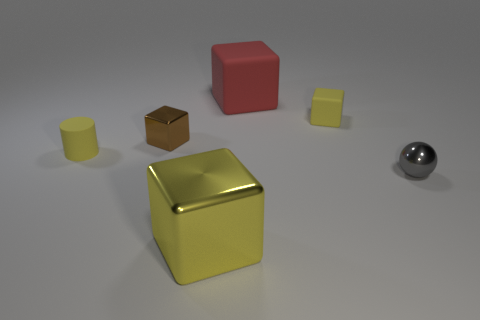What shape is the yellow object that is on the left side of the big red thing and behind the tiny metallic ball?
Your answer should be compact. Cylinder. Is the number of large red matte cubes that are to the left of the big yellow block the same as the number of tiny gray cylinders?
Keep it short and to the point. Yes. What number of objects are big red blocks or gray shiny spheres that are right of the yellow cylinder?
Your answer should be compact. 2. Is there another metal thing of the same shape as the brown thing?
Your answer should be compact. Yes. Is the number of tiny metallic objects behind the large red matte block the same as the number of small yellow matte blocks behind the metal ball?
Provide a short and direct response. No. Is there any other thing that is the same size as the rubber cylinder?
Offer a very short reply. Yes. How many gray objects are large shiny blocks or cylinders?
Your answer should be compact. 0. How many yellow metal cubes have the same size as the sphere?
Give a very brief answer. 0. There is a object that is both behind the sphere and on the right side of the large red rubber thing; what color is it?
Your response must be concise. Yellow. Is the number of tiny metallic cubes to the right of the tiny gray ball greater than the number of big green metallic things?
Your answer should be very brief. No. 